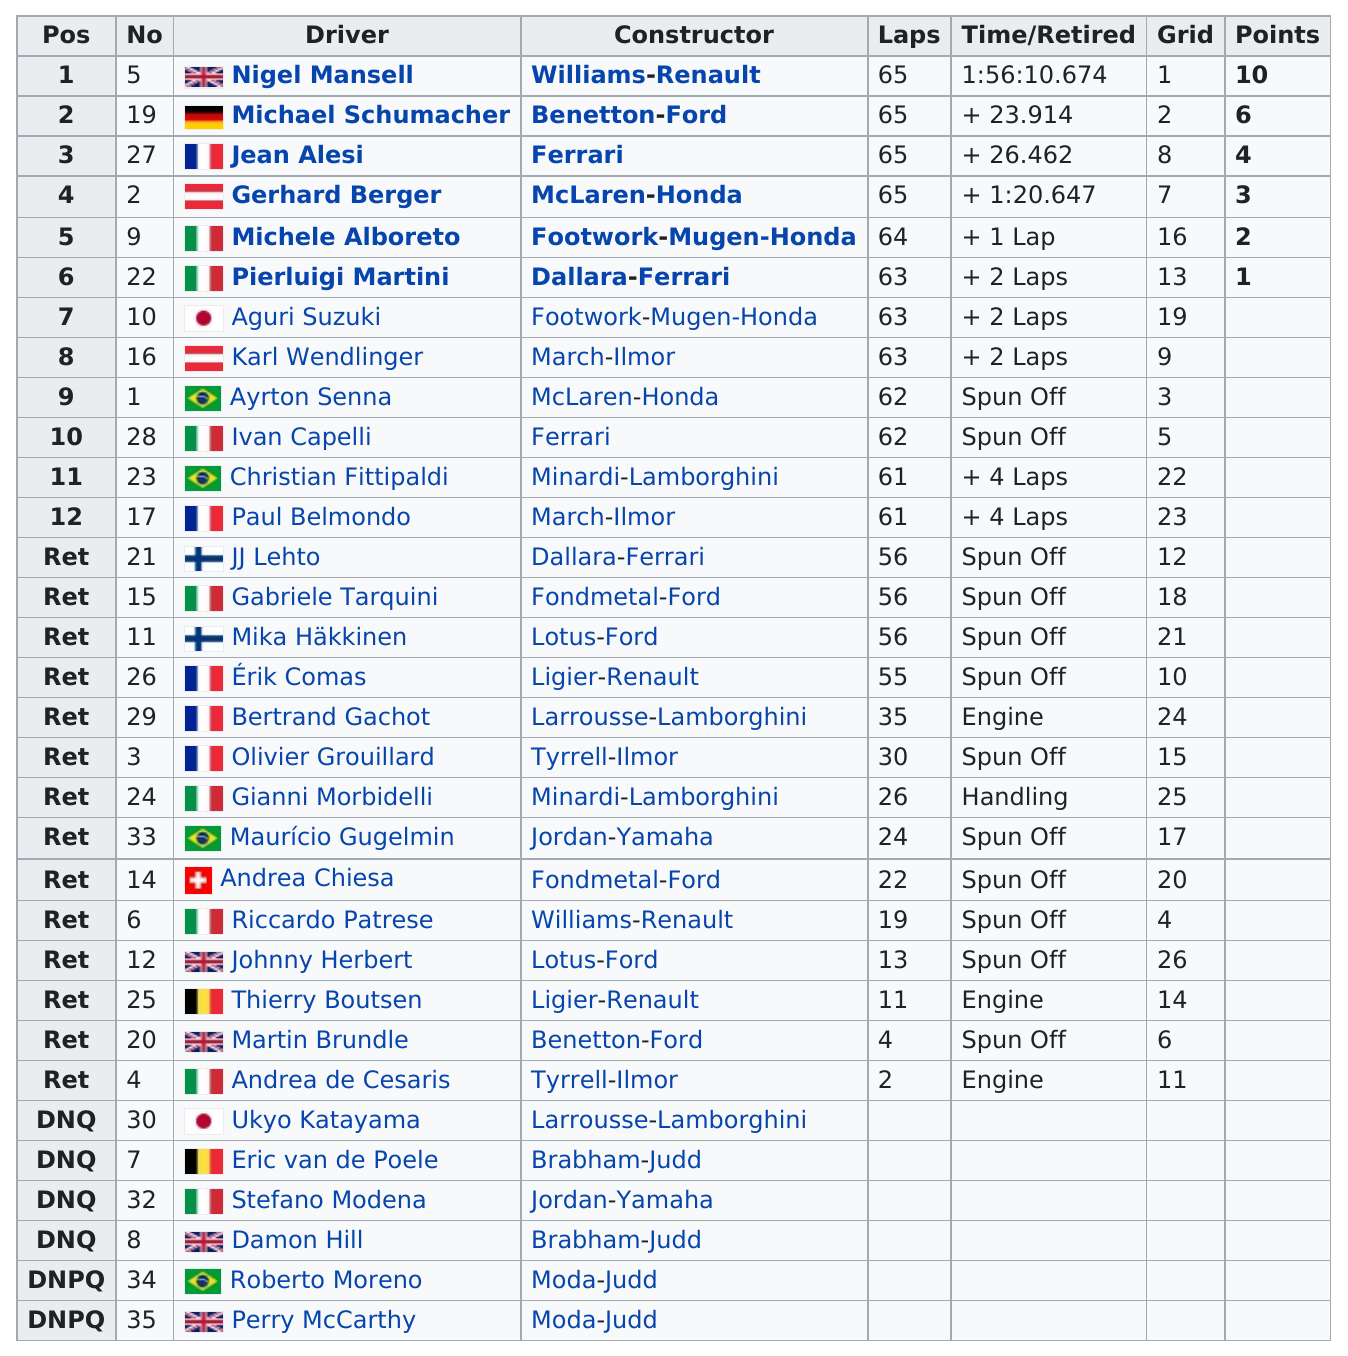Point out several critical features in this image. The number of drivers from France is greater than the number of drivers from Italy. Andrea Chiesa is the only driver from Switzerland. Eight drivers were from Italy. The driver who did not score fewer than 7 points was Nigel Mansell. In total, the points for all 26 questions are 26. 